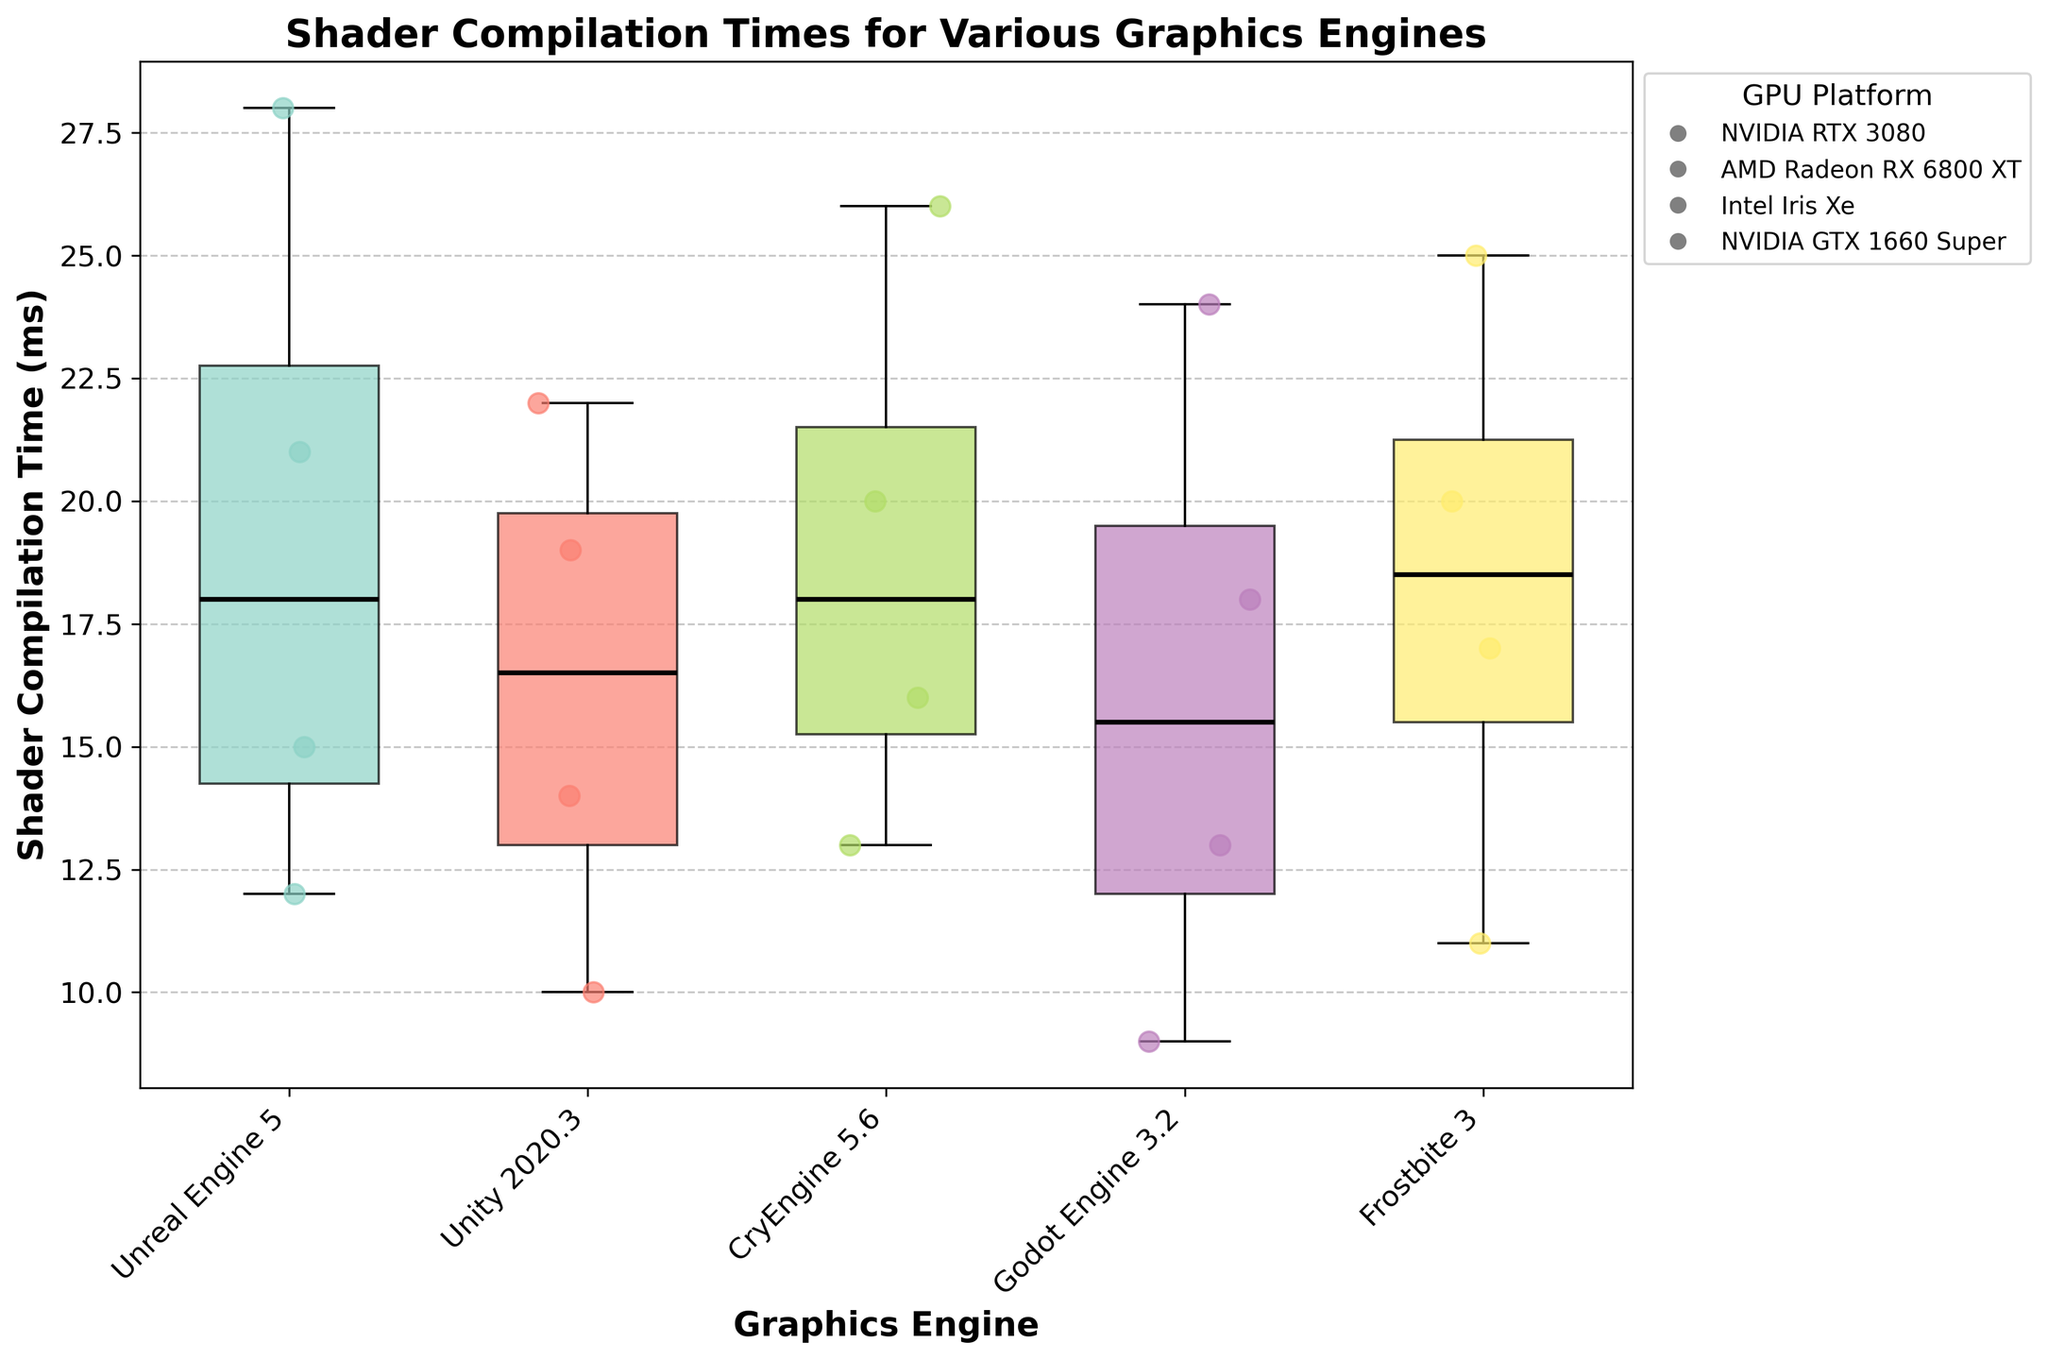Which graphics engine has the highest median shader compilation time? By examining the figure, locate the median lines inside each box. The engine with the highest median line represents the highest median compilation time.
Answer: Unreal Engine 5 Which GPU platform consistently shows the lowest shader compilation time across all engines? Analyze the scatter points on the box plot and identify the GPU platform whose points are consistently lowest across all engines.
Answer: NVIDIA RTX 3080 What is the difference in median shader compilation times between Godot Engine and Frostbite 3? Compare the median lines within the boxes of Godot Engine and Frostbite 3. Measure the vertical distance between these medians to find the difference.
Answer: 2 ms Which graphics engine has the widest range of shader compilation times? The range is the difference between the highest and lowest points (whiskers) of the box plots. Identify the box plot with the longest vertical span.
Answer: Unreal Engine 5 Are there any outliers in the shader compilation times for Unity 2020.3? Look closely at the scatter points outside the whiskers of the Unity 2020.3 box plot. If there are any such points, they are considered outliers.
Answer: No Between Unreal Engine 5 and CryEngine 5.6, which has a tighter distribution of shader compilation times? A tighter distribution means a smaller interquartile range (IQR), which is the height of the box. Compare the heights of the boxes for Unreal Engine 5 and CryEngine 5.6.
Answer: CryEngine 5.6 Which GPU platform shows the largest variance in shader compilation times for Frostbite 3? For Frostbite 3, examine the spread of scatter points for each GPU platform. The platform with points that are more spread out has the largest variance.
Answer: Intel Iris Xe How many unique graphics engines are being compared in the figure? Count the number of unique labels on the x-axis of the box plot, representing different graphics engines.
Answer: 5 Which GPU platform has no outliers in shader compilation times for any engine? Identify the GPU platform by examining the scatter points for each engine and checking if none lie outside the whiskers for any engine's box plot.
Answer: NVIDIA RTX 3080 